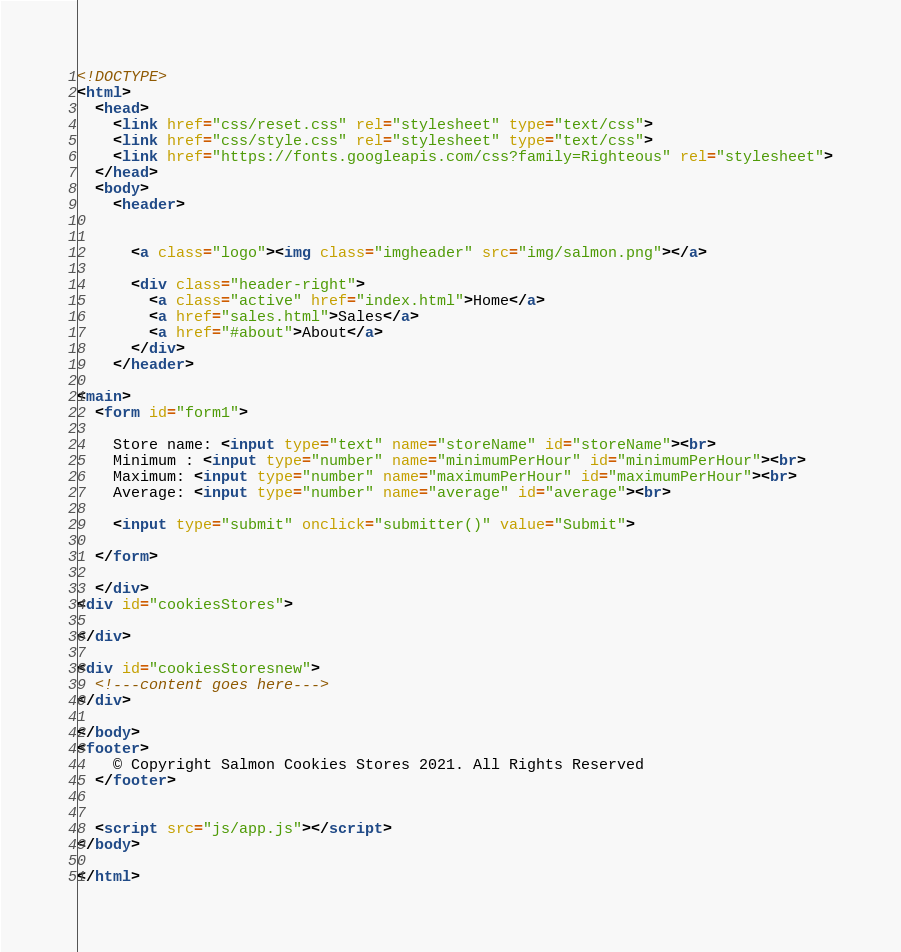Convert code to text. <code><loc_0><loc_0><loc_500><loc_500><_HTML_><!DOCTYPE>
<html>
  <head>
    <link href="css/reset.css" rel="stylesheet" type="text/css">
    <link href="css/style.css" rel="stylesheet" type="text/css">
    <link href="https://fonts.googleapis.com/css?family=Righteous" rel="stylesheet">
  </head>
  <body>
    <header>
     

      <a class="logo"><img class="imgheader" src="img/salmon.png"></a>
      
      <div class="header-right">
        <a class="active" href="index.html">Home</a>
        <a href="sales.html">Sales</a>
        <a href="#about">About</a>
      </div>
    </header>

<main>
  <form id="form1">
    
    Store name: <input type="text" name="storeName" id="storeName"><br>
    Minimum : <input type="number" name="minimumPerHour" id="minimumPerHour"><br>
    Maximum: <input type="number" name="maximumPerHour" id="maximumPerHour"><br>
    Average: <input type="number" name="average" id="average"><br>

    <input type="submit" onclick="submitter()" value="Submit">
  
  </form>

  </div>
<div id="cookiesStores">

</div>

<div id="cookiesStoresnew">
  <!---content goes here--->
</div>

</body>
<footer>
    © Copyright Salmon Cookies Stores 2021. All Rights Reserved
  </footer>


  <script src="js/app.js"></script>
</body>

</html></code> 